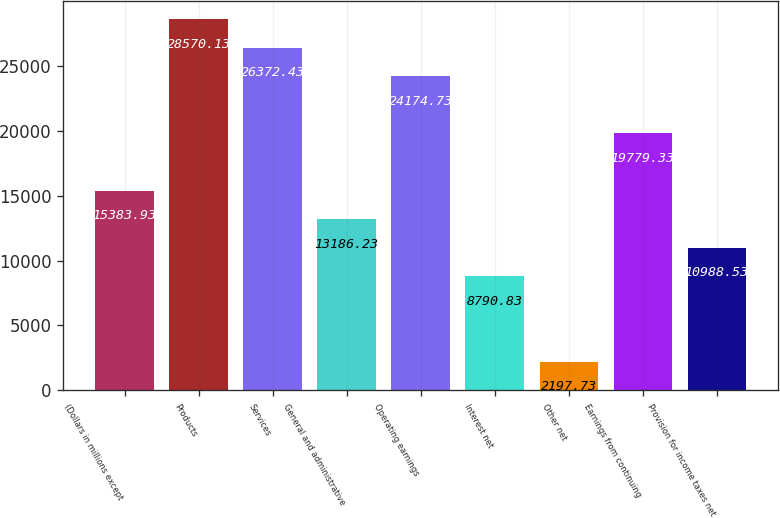Convert chart. <chart><loc_0><loc_0><loc_500><loc_500><bar_chart><fcel>(Dollars in millions except<fcel>Products<fcel>Services<fcel>General and administrative<fcel>Operating earnings<fcel>Interest net<fcel>Other net<fcel>Earnings from continuing<fcel>Provision for income taxes net<nl><fcel>15383.9<fcel>28570.1<fcel>26372.4<fcel>13186.2<fcel>24174.7<fcel>8790.83<fcel>2197.73<fcel>19779.3<fcel>10988.5<nl></chart> 